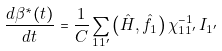Convert formula to latex. <formula><loc_0><loc_0><loc_500><loc_500>\frac { d \beta ^ { * } ( t ) } { d t } = \frac { 1 } { C } \sum _ { 1 1 ^ { \prime } } \left ( \hat { H } , \hat { f } _ { 1 } \right ) \chi ^ { - 1 } _ { 1 1 ^ { \prime } } \, I _ { 1 ^ { \prime } }</formula> 